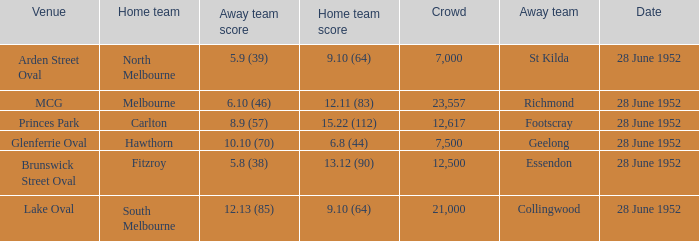Who is the away side when north melbourne is at home and has a score of 9.10 (64)? St Kilda. 